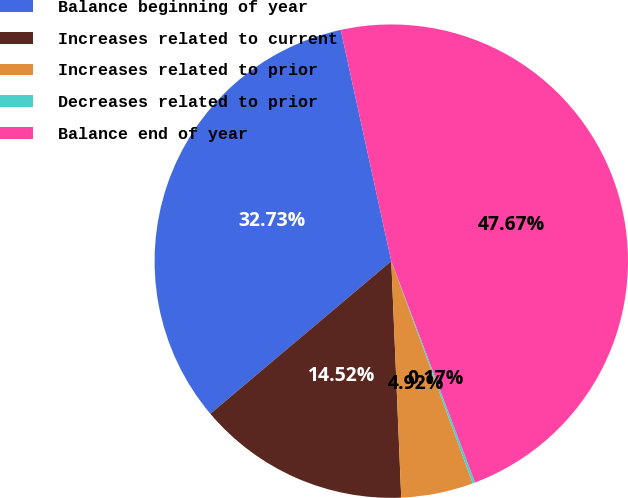<chart> <loc_0><loc_0><loc_500><loc_500><pie_chart><fcel>Balance beginning of year<fcel>Increases related to current<fcel>Increases related to prior<fcel>Decreases related to prior<fcel>Balance end of year<nl><fcel>32.73%<fcel>14.52%<fcel>4.92%<fcel>0.17%<fcel>47.67%<nl></chart> 